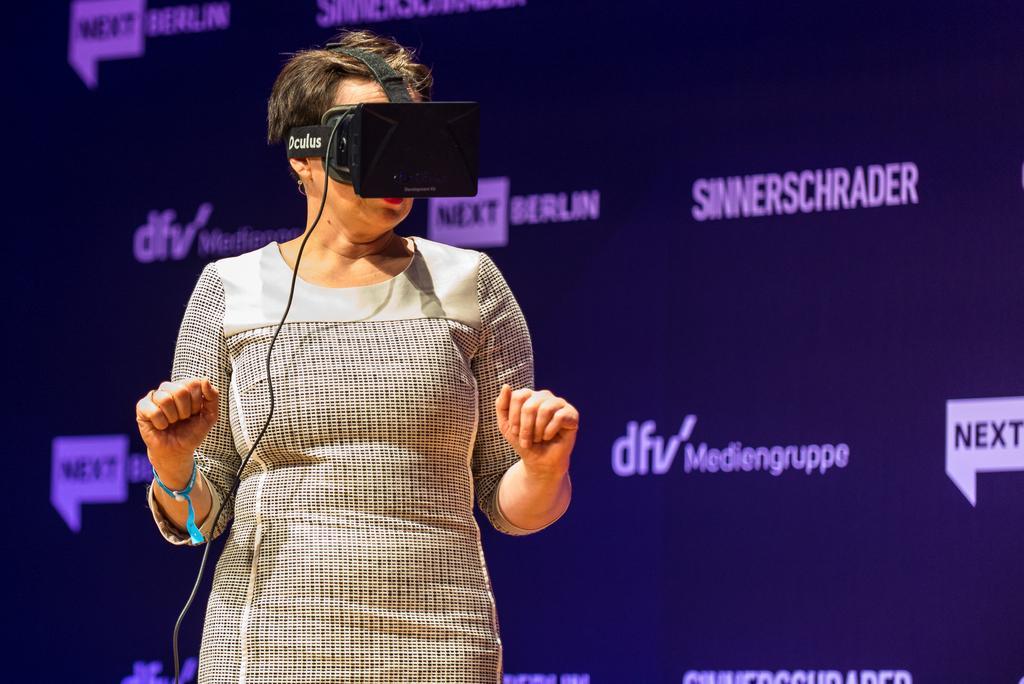Please provide a concise description of this image. This image is taken indoors. In the background there is a board with a text on it. In the middle of the image a woman is standing and she has worn a virtual 3D device. 